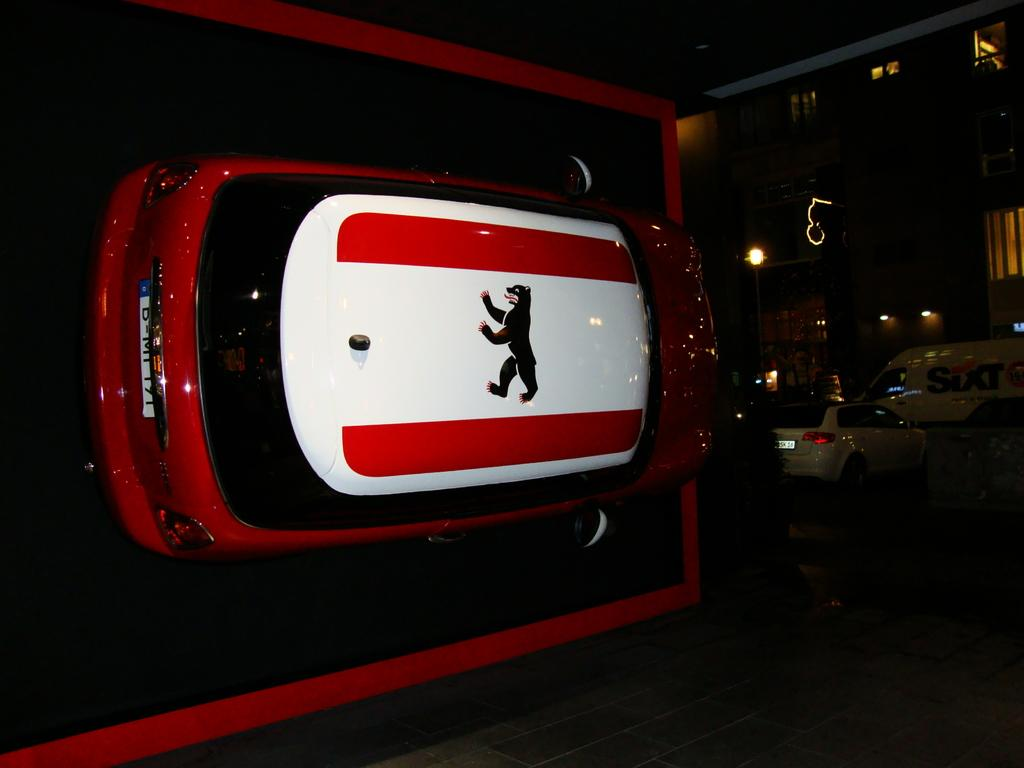What is placed on the floor in the image? There is a car on the floor in the image. Can you describe the colors of the car? The car is red and white. What else can be seen on the road in the image? There are vehicles visible on the road in the image. How would you describe the lighting in the image? The background of the image is dark. What is the income of the person driving the car in the image? There is no information about the person driving the car or their income in the image. Can you describe the teeth of the person driving the car in the image? There is no person or their teeth visible in the image. 